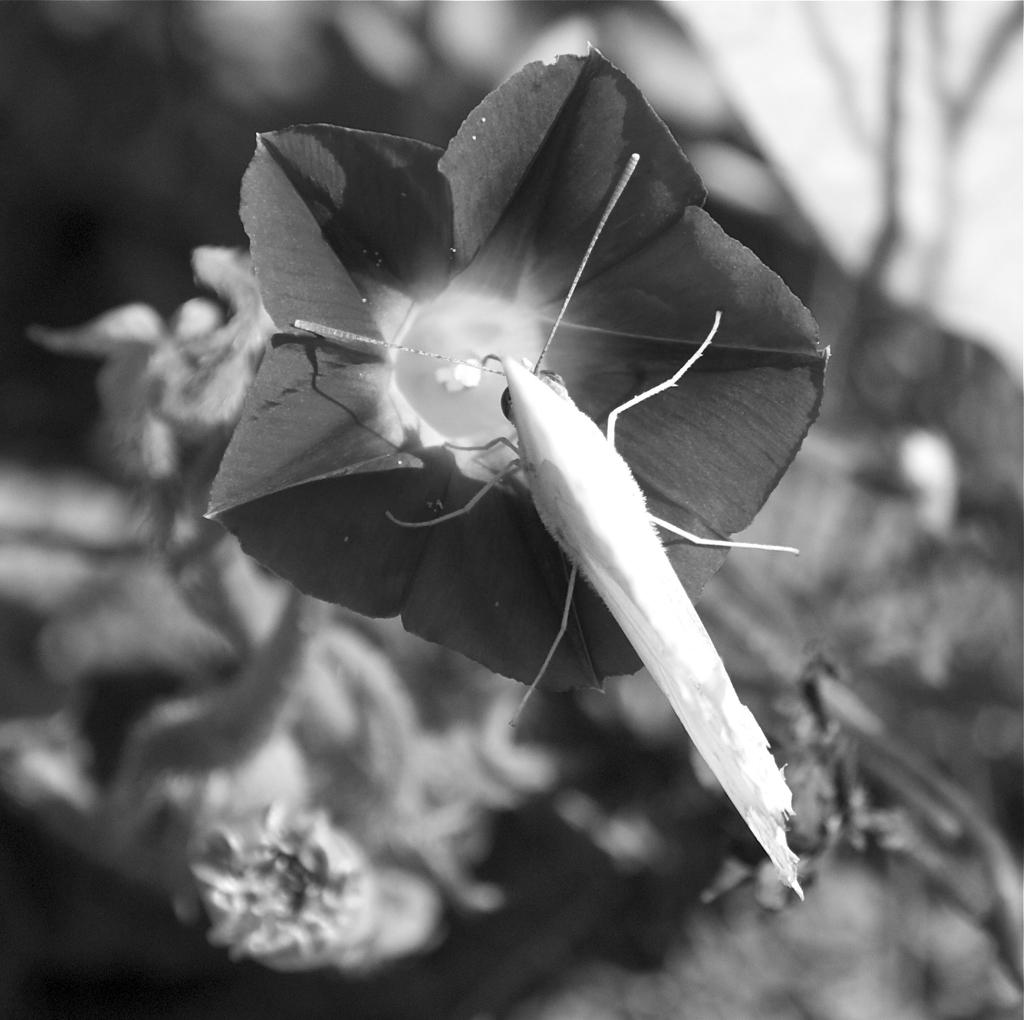What is the color scheme of the image? The image is black and white. What can be seen in the image? There is an insect on a flower in the image. How is the background of the image depicted? The background of the image is blurred. How does the insect express anger in the image? There is no indication of the insect expressing anger in the image, as insects do not have the ability to express emotions like humans. 